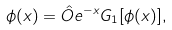<formula> <loc_0><loc_0><loc_500><loc_500>\phi ( x ) = \hat { O } e ^ { - x } G _ { 1 } [ \phi ( x ) ] ,</formula> 